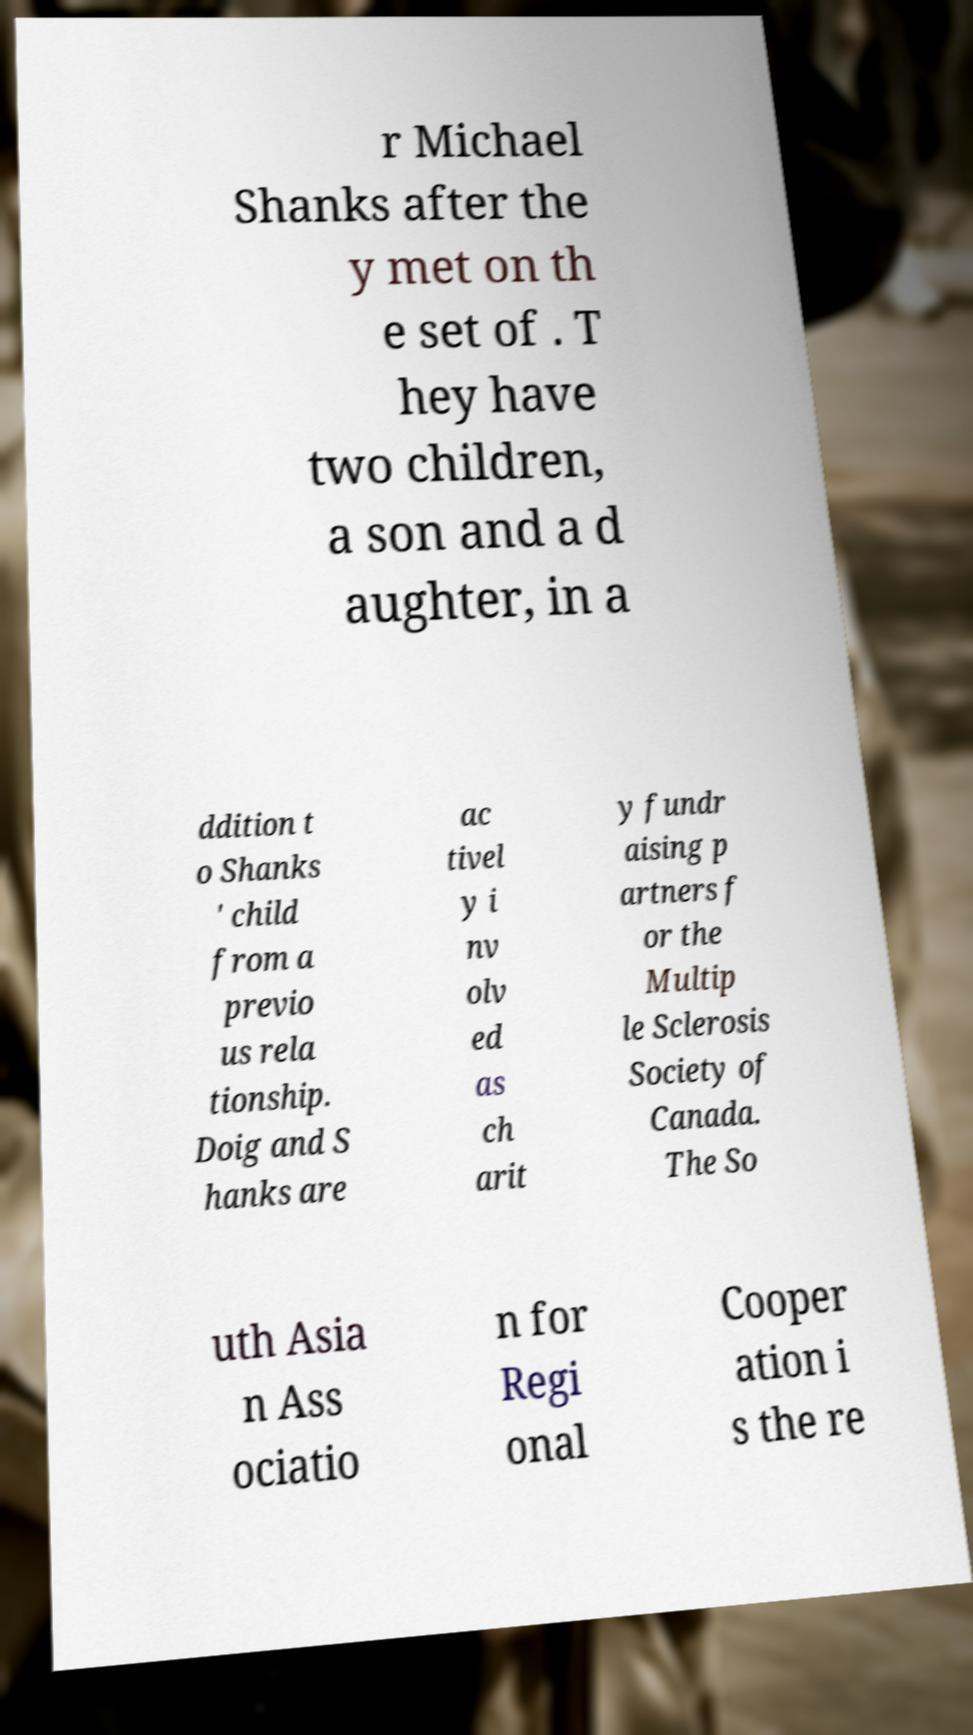There's text embedded in this image that I need extracted. Can you transcribe it verbatim? r Michael Shanks after the y met on th e set of . T hey have two children, a son and a d aughter, in a ddition t o Shanks ' child from a previo us rela tionship. Doig and S hanks are ac tivel y i nv olv ed as ch arit y fundr aising p artners f or the Multip le Sclerosis Society of Canada. The So uth Asia n Ass ociatio n for Regi onal Cooper ation i s the re 